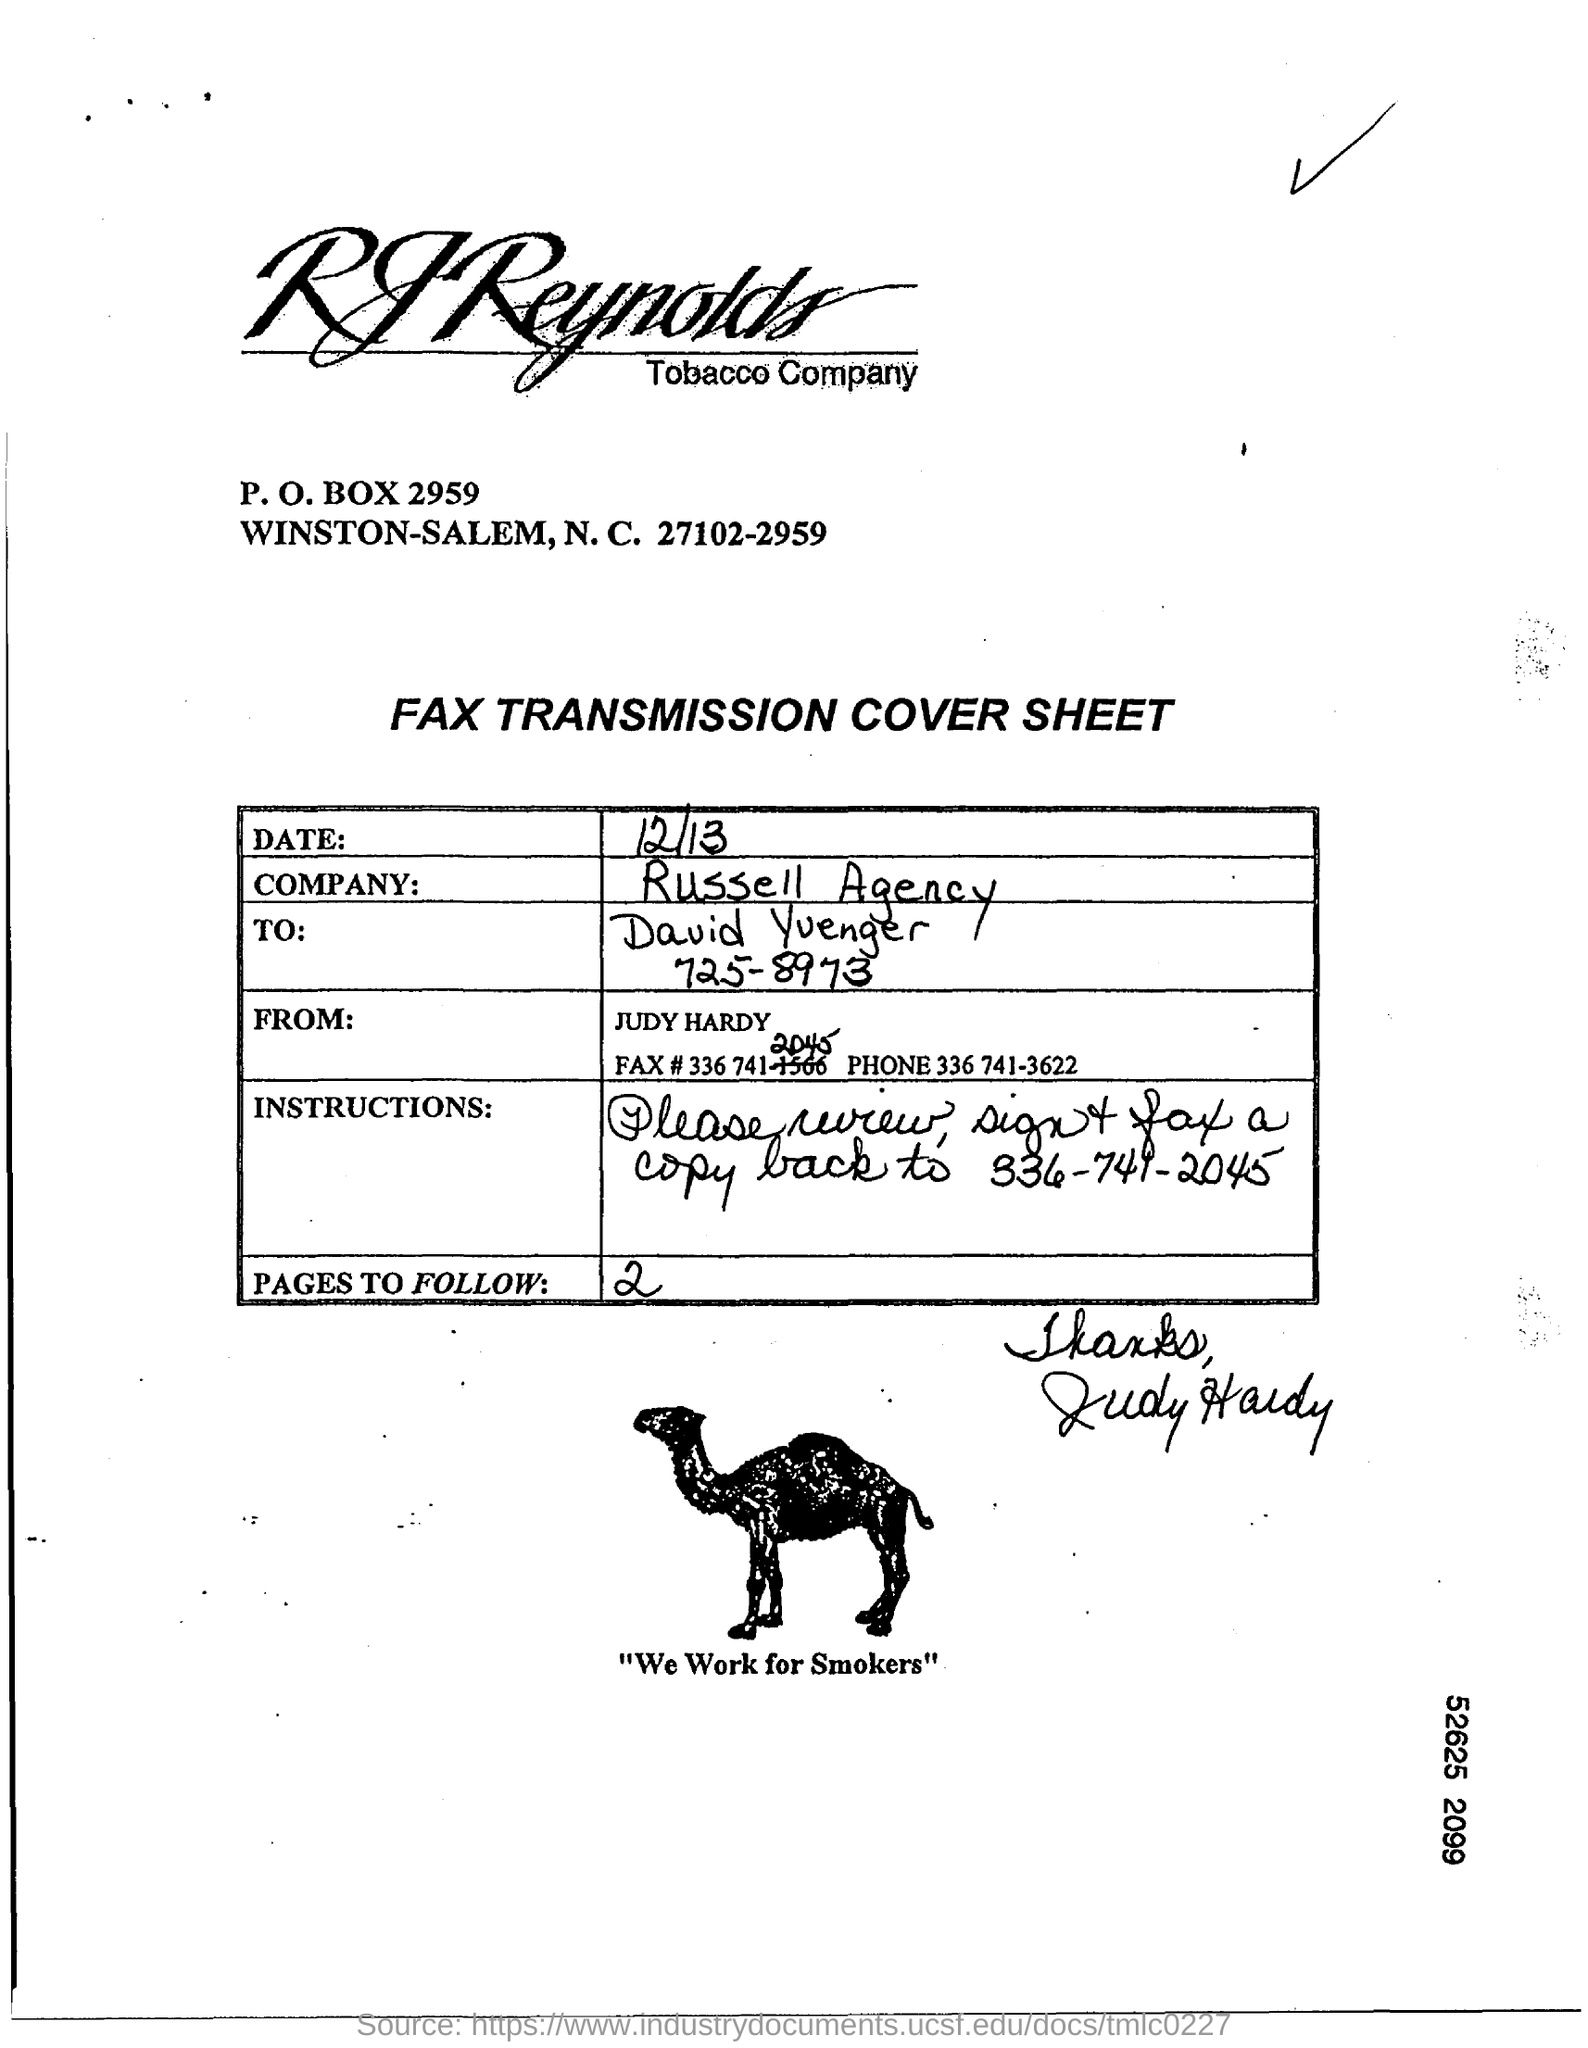Indicate a few pertinent items in this graphic. The phone number of Judy Hardy is 336-741-3622. The text written below the picture of a camel reads, 'We work for smokers.' The P.O. Box is a specified point of receipt and collection of mail and packages, located at 2959. 